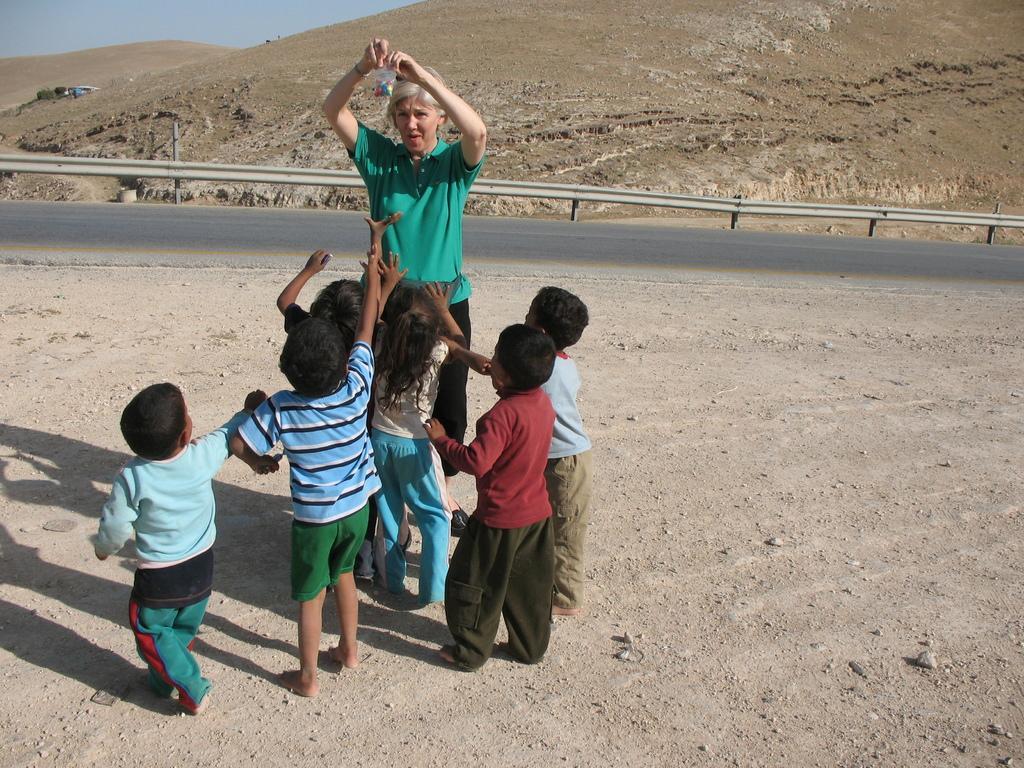Could you give a brief overview of what you see in this image? In this image there are persons standing. In the background there is a fence and there is a road and there are mountains. 